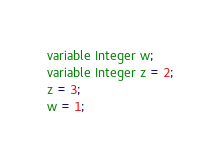<code> <loc_0><loc_0><loc_500><loc_500><_Ceylon_>variable Integer w;
variable Integer z = 2;
z = 3;
w = 1;
</code> 